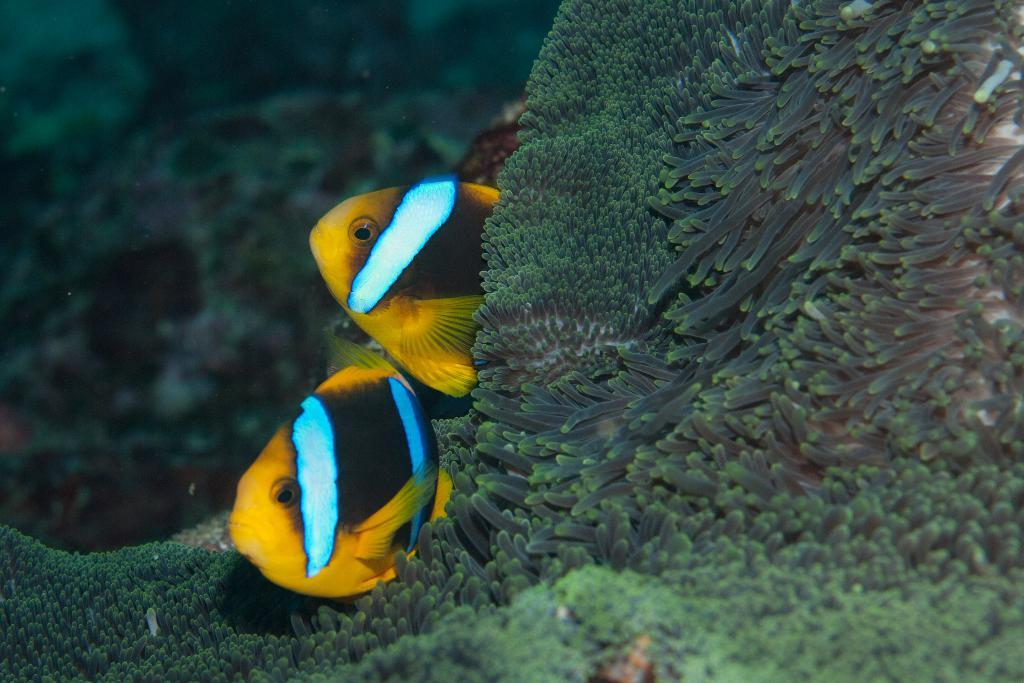What animals are present in the image? There are two fishes in the image. Where are the fishes located? The fishes are in the water. What can be seen in the background of the image? There is coral reef visible in the background of the image. What type of company is conducting business in the image? There is no company present in the image; it features two fishes in the water with a coral reef background. What direction is the current flowing in the image? There is no current visible in the image, as it is focused on the fishes and coral reef. 